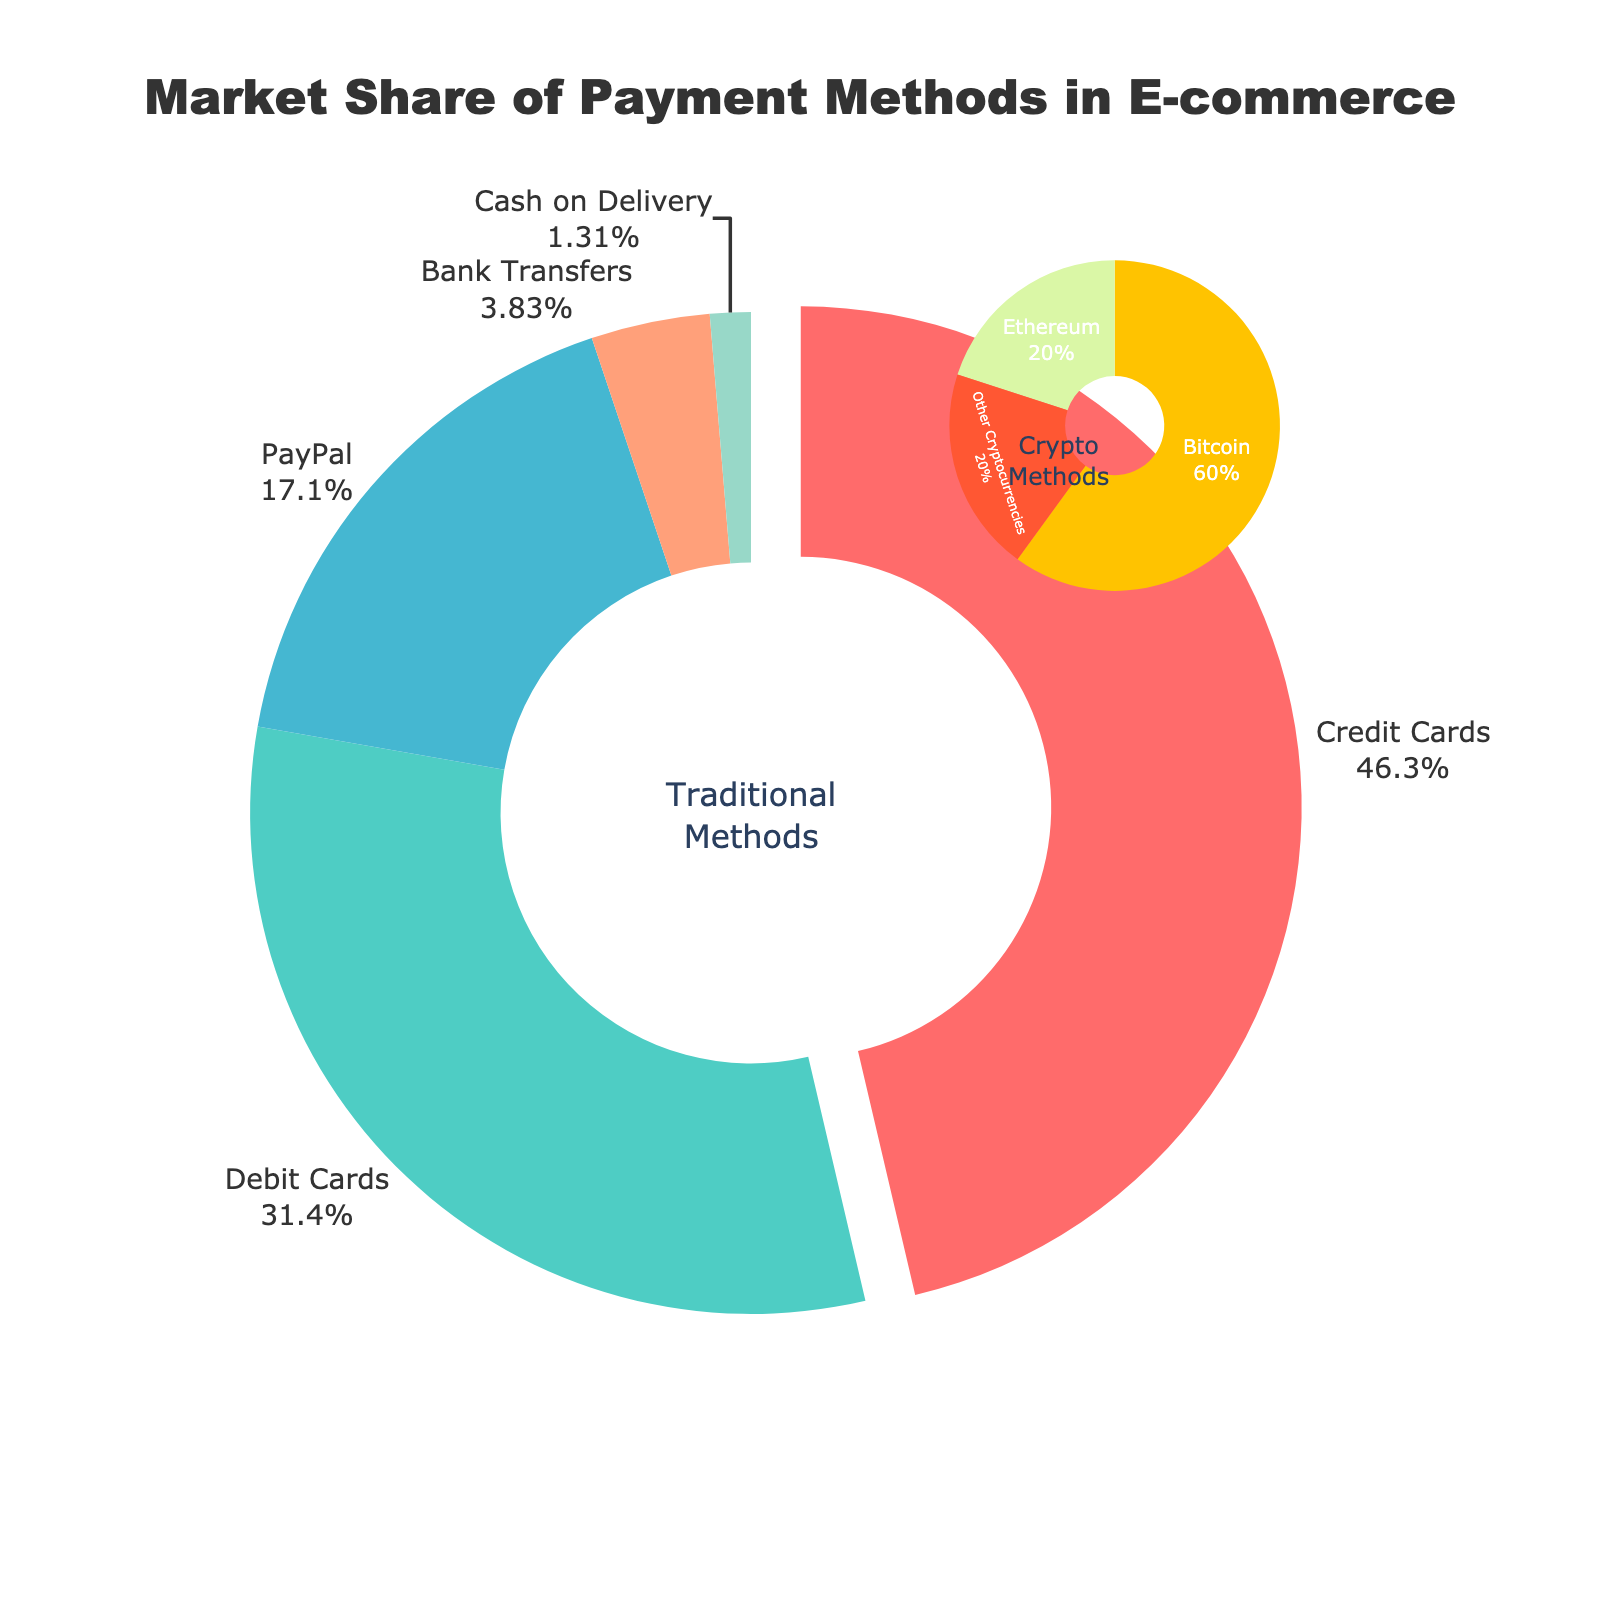what is the combined market share of Bitcoin and Ethereum? To find the combined market share of Bitcoin and Ethereum, add their individual market shares together: 0.3% + 0.1% = 0.4%.
Answer: 0.4% Which payment method has the largest market share? According to the figure, Credit Cards have the highest market share at 42.3%.
Answer: Credit Cards Which payment method has a market share closest to 30%? Debit Cards have a market share of 28.7%, which is the closest value to 30%.
Answer: Debit Cards How much larger is the market share of PayPal compared to Bitcoin? Subtract the market share of Bitcoin from PayPal: 15.6% - 0.3% = 15.3%.
Answer: 15.3% List the traditional payment methods in the order of their market share from highest to lowest. The traditional payment methods by market share from highest to lowest are: Credit Cards (42.3%), Debit Cards (28.7%), PayPal (15.6%), Bank Transfers (3.5%), Cash on Delivery (1.2%).
Answer: Credit Cards, Debit Cards, PayPal, Bank Transfers, Cash on Delivery What is the total market share of traditional payment methods? Add the market shares of all traditional methods: 42.3% (Credit Cards) + 28.7% (Debit Cards) + 15.6% (PayPal) + 3.5% (Bank Transfers) + 1.2% (Cash on Delivery) = 91.3%.
Answer: 91.3% What is the difference between the market shares of traditional and crypto methods? The market share of traditional methods is 91.3%, and for crypto methods, it is 0.5% (0.3% for Bitcoin, 0.1% for Ethereum, and 0.1% for Other Cryptocurrencies). So, the difference is 91.3% - 0.5% = 90.8%.
Answer: 90.8% Which payment methods are depicted in blue in the main pie chart? According to the visual layout, Bank Transfers are shown in blue in the main pie chart.
Answer: Bank Transfers 